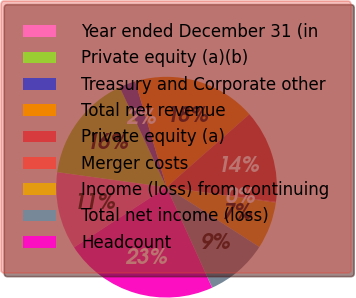Convert chart. <chart><loc_0><loc_0><loc_500><loc_500><pie_chart><fcel>Year ended December 31 (in<fcel>Private equity (a)(b)<fcel>Treasury and Corporate other<fcel>Total net revenue<fcel>Private equity (a)<fcel>Merger costs<fcel>Income (loss) from continuing<fcel>Total net income (loss)<fcel>Headcount<nl><fcel>11.36%<fcel>15.85%<fcel>2.38%<fcel>18.1%<fcel>13.61%<fcel>0.13%<fcel>6.87%<fcel>9.11%<fcel>22.59%<nl></chart> 